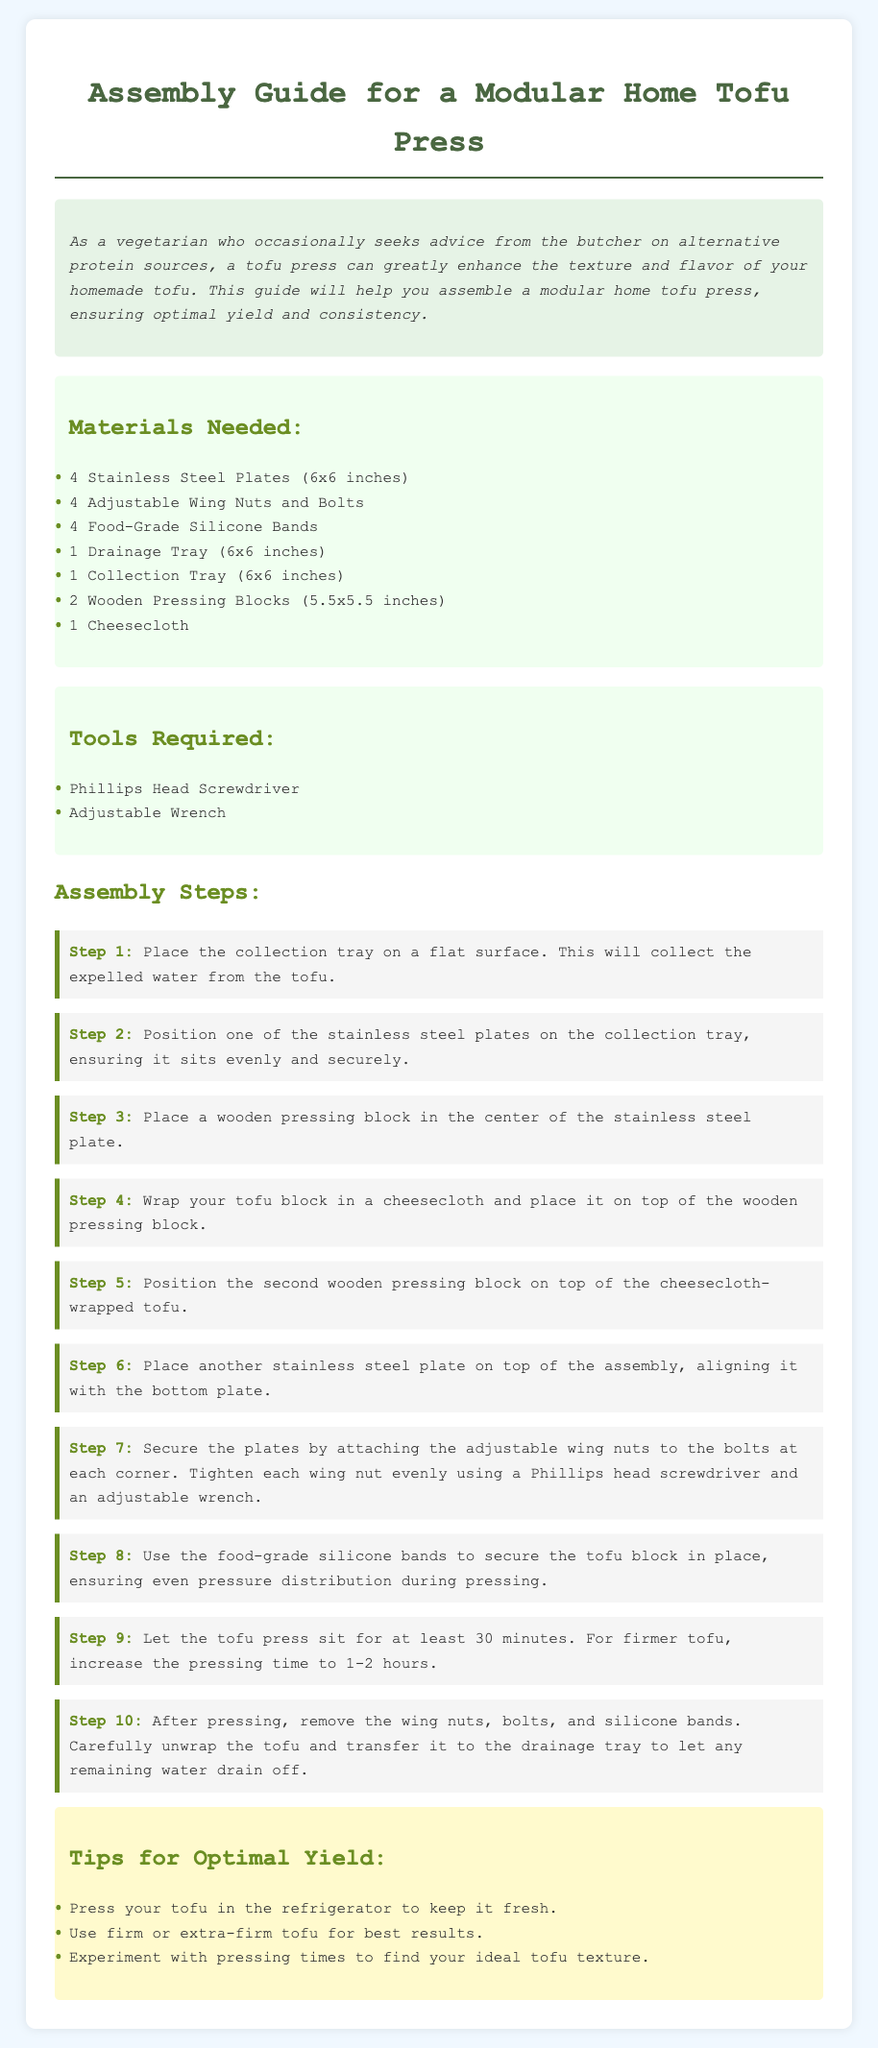What is the size of the stainless steel plates? The document specifies that the stainless steel plates are 6x6 inches in size.
Answer: 6x6 inches How many wooden pressing blocks are needed? The guide states that two wooden pressing blocks are required for the assembly.
Answer: 2 What tool is required to tighten the wing nuts? The assembly instructions mention using a Phillips head screwdriver to tighten the wing nuts.
Answer: Phillips head screwdriver What is placed on top of the tofu during pressing? The instructions indicate that a second wooden pressing block is placed on top of the cheesecloth-wrapped tofu.
Answer: Wooden pressing block What is the minimum pressing time suggested? The document suggests letting the tofu press sit for at least 30 minutes during the pressing process.
Answer: 30 minutes What color is used for the background of the document? The background color of the document is light blue, referred to in the style section.
Answer: Light blue How do you secure the tofu block during pressing? The instructions recommend using food-grade silicone bands to secure the tofu block in place.
Answer: Food-grade silicone bands What type of tofu is recommended for best results? The tips section suggests using firm or extra-firm tofu for optimal results.
Answer: Firm or extra-firm tofu 